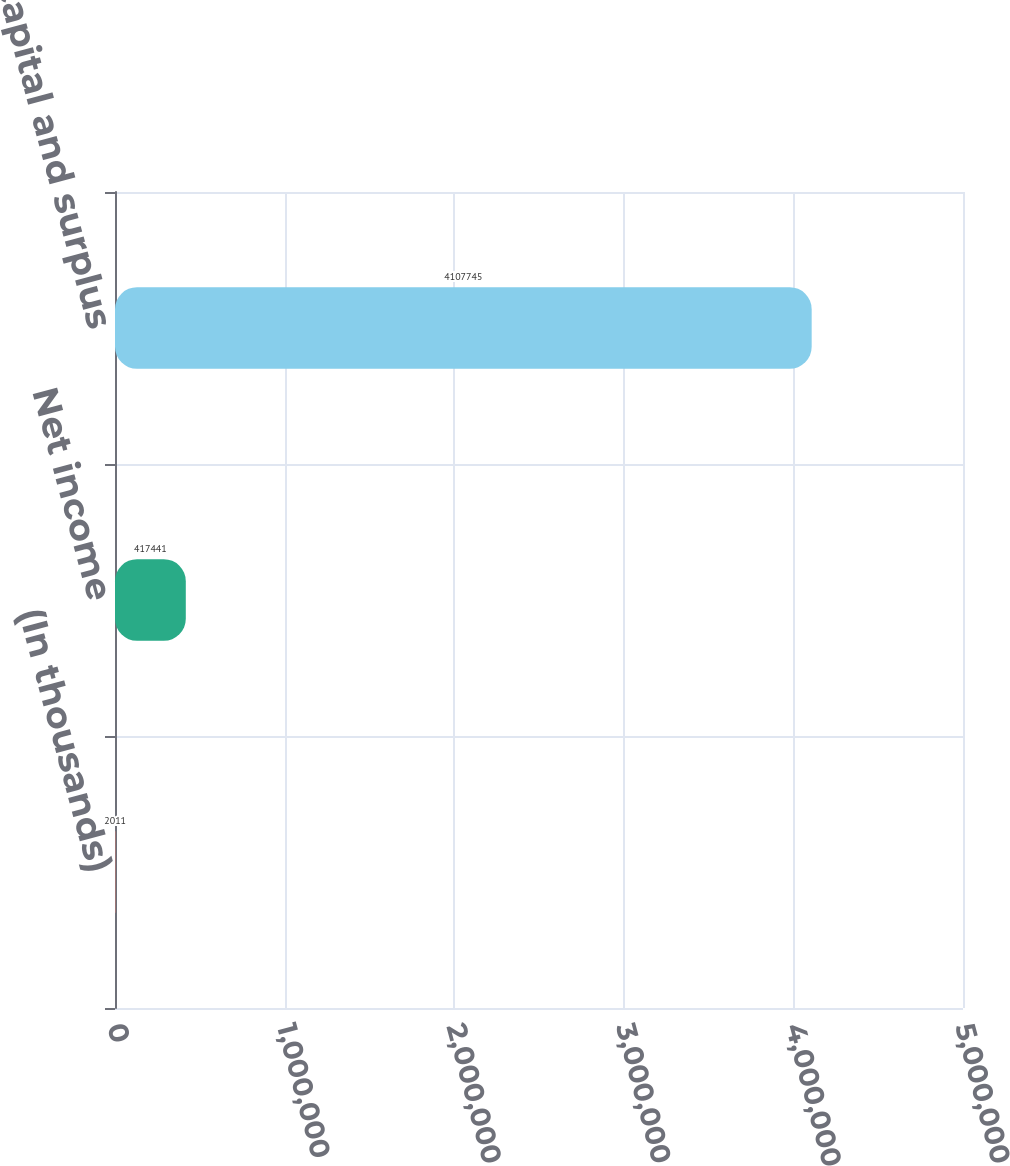Convert chart to OTSL. <chart><loc_0><loc_0><loc_500><loc_500><bar_chart><fcel>(In thousands)<fcel>Net income<fcel>Statutory capital and surplus<nl><fcel>2011<fcel>417441<fcel>4.10774e+06<nl></chart> 